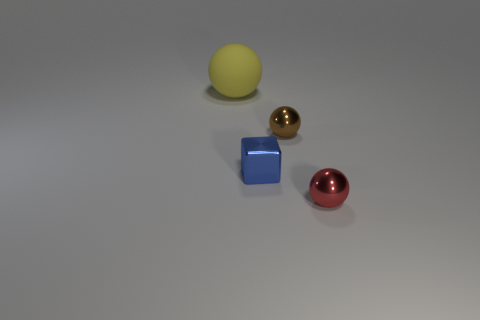Subtract all green cubes. Subtract all yellow balls. How many cubes are left? 1 Add 4 tiny purple balls. How many objects exist? 8 Subtract all balls. How many objects are left? 1 Subtract all metallic cubes. Subtract all large spheres. How many objects are left? 2 Add 2 metal blocks. How many metal blocks are left? 3 Add 1 spheres. How many spheres exist? 4 Subtract 0 cyan spheres. How many objects are left? 4 